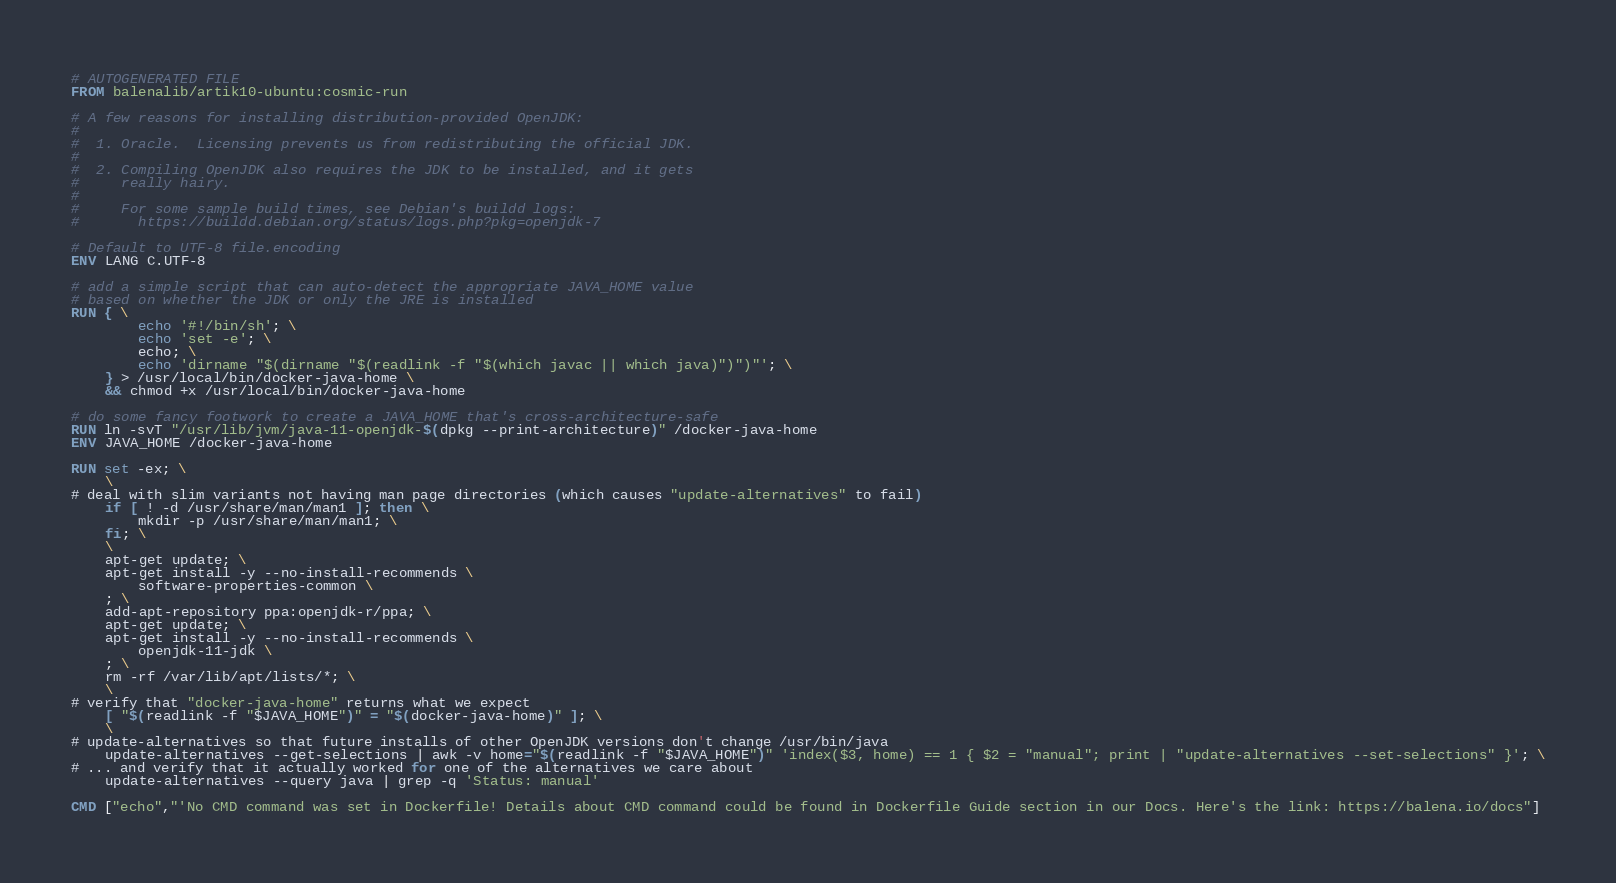<code> <loc_0><loc_0><loc_500><loc_500><_Dockerfile_># AUTOGENERATED FILE
FROM balenalib/artik10-ubuntu:cosmic-run

# A few reasons for installing distribution-provided OpenJDK:
#
#  1. Oracle.  Licensing prevents us from redistributing the official JDK.
#
#  2. Compiling OpenJDK also requires the JDK to be installed, and it gets
#     really hairy.
#
#     For some sample build times, see Debian's buildd logs:
#       https://buildd.debian.org/status/logs.php?pkg=openjdk-7

# Default to UTF-8 file.encoding
ENV LANG C.UTF-8

# add a simple script that can auto-detect the appropriate JAVA_HOME value
# based on whether the JDK or only the JRE is installed
RUN { \
		echo '#!/bin/sh'; \
		echo 'set -e'; \
		echo; \
		echo 'dirname "$(dirname "$(readlink -f "$(which javac || which java)")")"'; \
	} > /usr/local/bin/docker-java-home \
	&& chmod +x /usr/local/bin/docker-java-home

# do some fancy footwork to create a JAVA_HOME that's cross-architecture-safe
RUN ln -svT "/usr/lib/jvm/java-11-openjdk-$(dpkg --print-architecture)" /docker-java-home
ENV JAVA_HOME /docker-java-home

RUN set -ex; \
	\
# deal with slim variants not having man page directories (which causes "update-alternatives" to fail)
	if [ ! -d /usr/share/man/man1 ]; then \
		mkdir -p /usr/share/man/man1; \
	fi; \
	\
	apt-get update; \
	apt-get install -y --no-install-recommends \
		software-properties-common \
	; \
	add-apt-repository ppa:openjdk-r/ppa; \
	apt-get update; \
	apt-get install -y --no-install-recommends \
		openjdk-11-jdk \
	; \
	rm -rf /var/lib/apt/lists/*; \
	\
# verify that "docker-java-home" returns what we expect
	[ "$(readlink -f "$JAVA_HOME")" = "$(docker-java-home)" ]; \
	\
# update-alternatives so that future installs of other OpenJDK versions don't change /usr/bin/java
	update-alternatives --get-selections | awk -v home="$(readlink -f "$JAVA_HOME")" 'index($3, home) == 1 { $2 = "manual"; print | "update-alternatives --set-selections" }'; \
# ... and verify that it actually worked for one of the alternatives we care about
	update-alternatives --query java | grep -q 'Status: manual'

CMD ["echo","'No CMD command was set in Dockerfile! Details about CMD command could be found in Dockerfile Guide section in our Docs. Here's the link: https://balena.io/docs"]</code> 